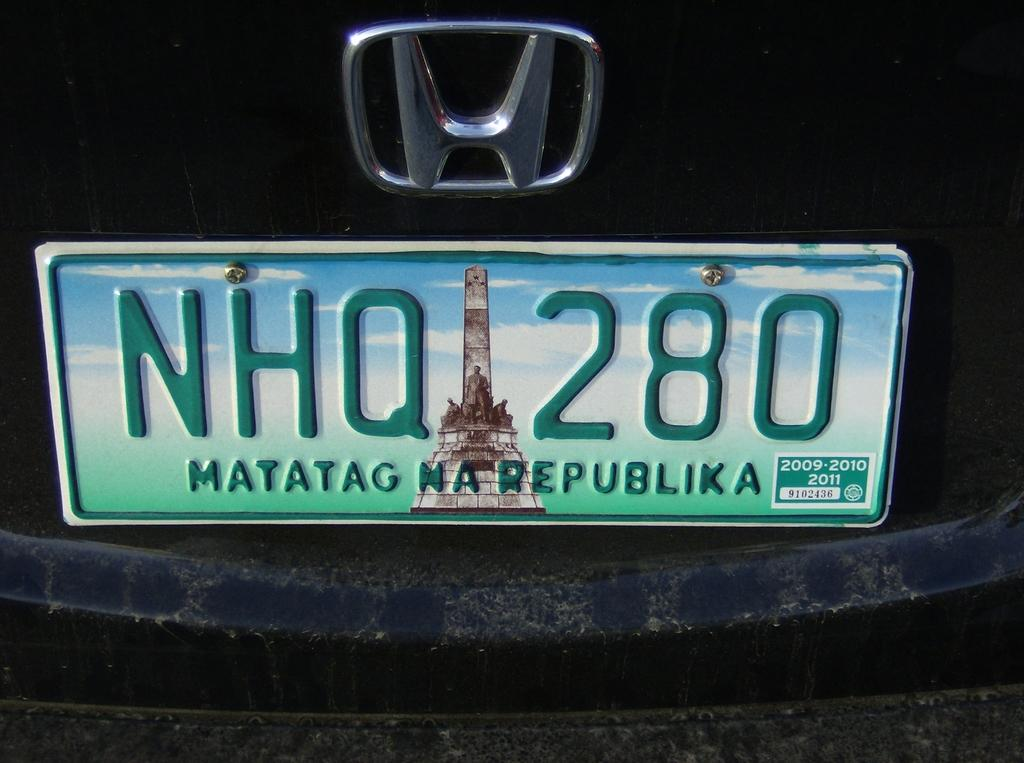<image>
Provide a brief description of the given image. A license place of a Honda car reads NHQ 280. 